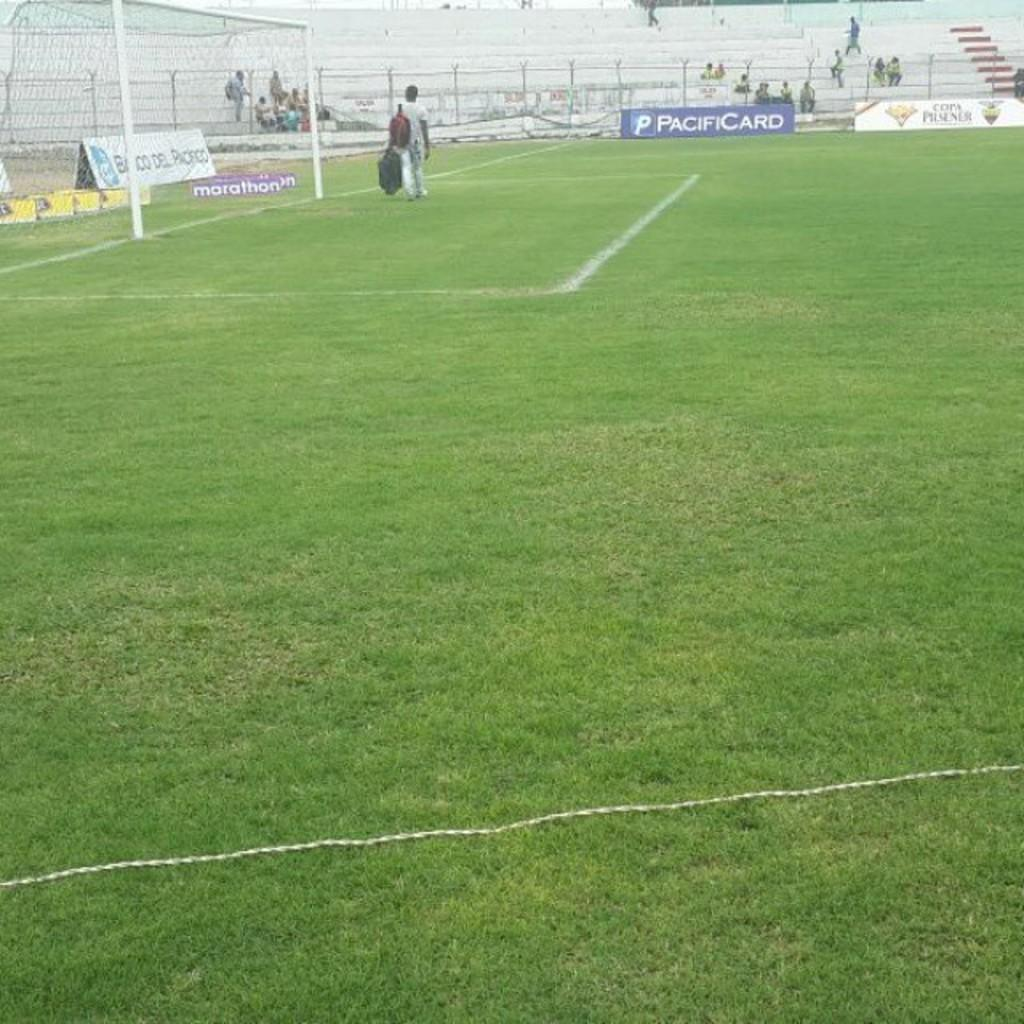<image>
Present a compact description of the photo's key features. An ad for PacifiCard is at the edge of the soccer field in front of some nearly-empty bleachers. 